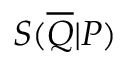<formula> <loc_0><loc_0><loc_500><loc_500>S ( \overline { Q } | P )</formula> 